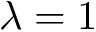Convert formula to latex. <formula><loc_0><loc_0><loc_500><loc_500>\lambda = 1</formula> 